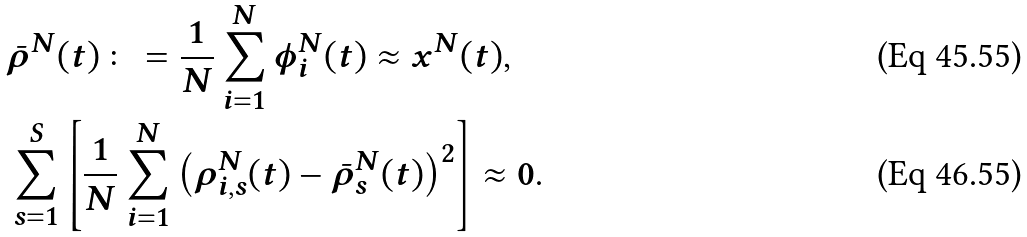Convert formula to latex. <formula><loc_0><loc_0><loc_500><loc_500>& \bar { \rho } ^ { N } ( t ) \colon = \frac { 1 } { N } \sum _ { i = 1 } ^ { N } \phi _ { i } ^ { N } ( t ) \approx x ^ { N } ( t ) , \\ & \sum _ { s = 1 } ^ { S } \left [ \frac { 1 } { N } \sum _ { i = 1 } ^ { N } \left ( \rho _ { i , s } ^ { N } ( t ) - \bar { \rho } _ { s } ^ { N } ( t ) \right ) ^ { 2 } \right ] \approx 0 .</formula> 